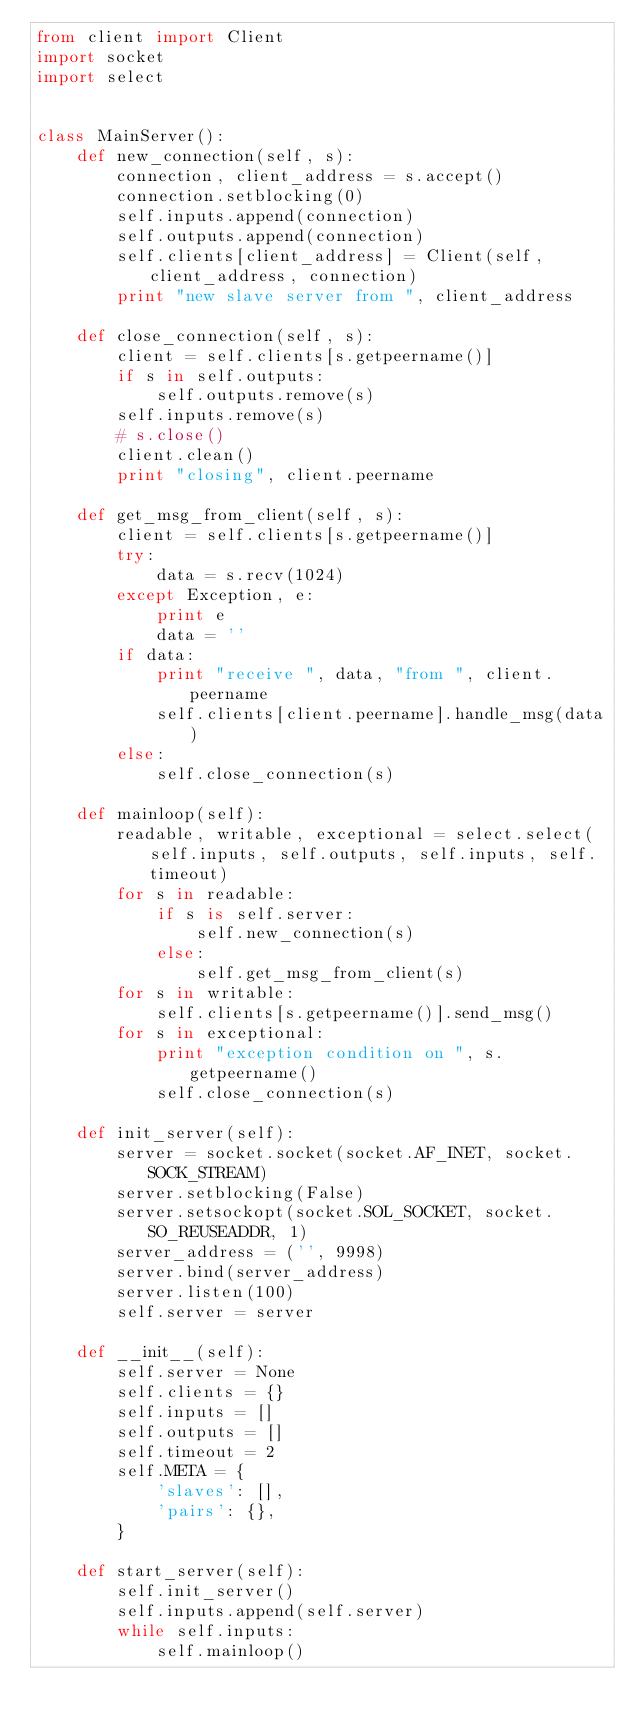Convert code to text. <code><loc_0><loc_0><loc_500><loc_500><_Python_>from client import Client
import socket
import select


class MainServer():
    def new_connection(self, s):
        connection, client_address = s.accept()
        connection.setblocking(0)
        self.inputs.append(connection)
        self.outputs.append(connection)
        self.clients[client_address] = Client(self, client_address, connection)
        print "new slave server from ", client_address

    def close_connection(self, s):
        client = self.clients[s.getpeername()]
        if s in self.outputs:
            self.outputs.remove(s)
        self.inputs.remove(s)
        # s.close()
        client.clean()
        print "closing", client.peername

    def get_msg_from_client(self, s):
        client = self.clients[s.getpeername()]
        try:
            data = s.recv(1024)
        except Exception, e:
            print e
            data = ''
        if data:
            print "receive ", data, "from ", client.peername
            self.clients[client.peername].handle_msg(data)
        else:
            self.close_connection(s)

    def mainloop(self):
        readable, writable, exceptional = select.select(self.inputs, self.outputs, self.inputs, self.timeout)
        for s in readable:
            if s is self.server:
                self.new_connection(s)
            else:
                self.get_msg_from_client(s)
        for s in writable:
            self.clients[s.getpeername()].send_msg()
        for s in exceptional:
            print "exception condition on ", s.getpeername()
            self.close_connection(s)

    def init_server(self):
        server = socket.socket(socket.AF_INET, socket.SOCK_STREAM)
        server.setblocking(False)
        server.setsockopt(socket.SOL_SOCKET, socket.SO_REUSEADDR, 1)
        server_address = ('', 9998)
        server.bind(server_address)
        server.listen(100)
        self.server = server

    def __init__(self):
        self.server = None
        self.clients = {}
        self.inputs = []
        self.outputs = []
        self.timeout = 2
        self.META = {
            'slaves': [],
            'pairs': {},
        }

    def start_server(self):
        self.init_server()
        self.inputs.append(self.server)
        while self.inputs:
            self.mainloop()
</code> 